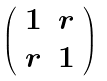<formula> <loc_0><loc_0><loc_500><loc_500>\left ( \begin{array} { c c } 1 & r \\ r & 1 \end{array} \right )</formula> 